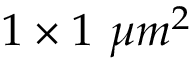Convert formula to latex. <formula><loc_0><loc_0><loc_500><loc_500>1 \times 1 \mu m ^ { 2 }</formula> 